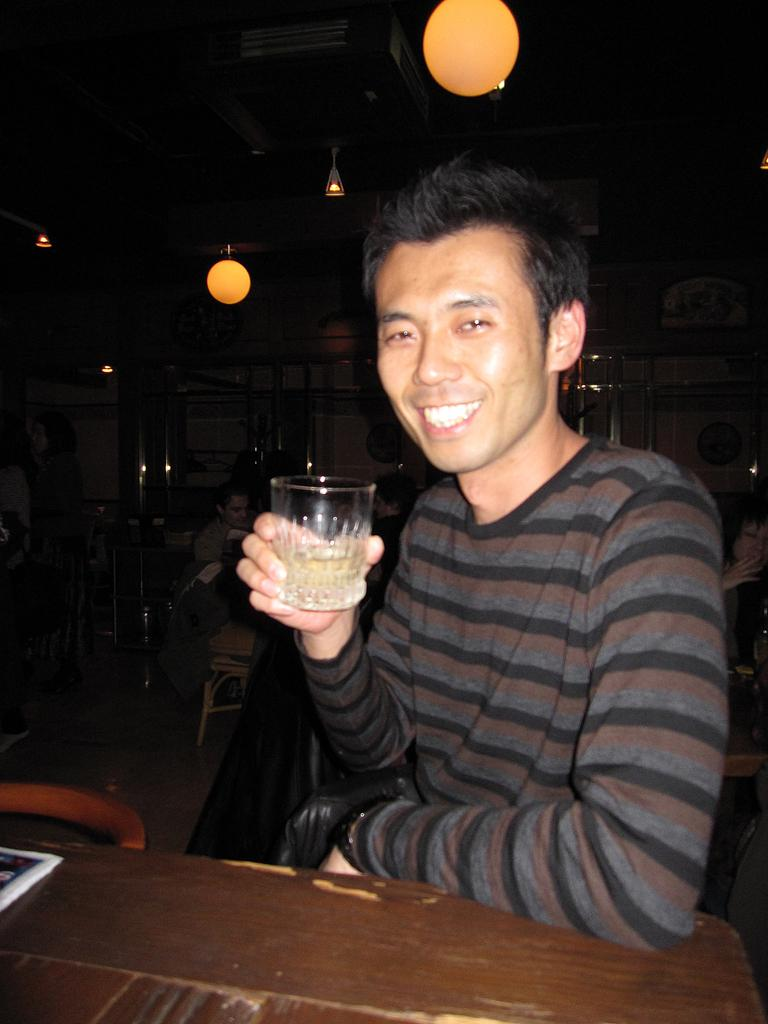Who is present in the image? There is a man in the image. What is the man holding in his hand? The man is holding a glass of wine in his hand. What is the man's facial expression in the image? The man is smiling. What type of house can be seen in the background of the image? There is no house visible in the image; it only features a man holding a glass of wine and smiling. 